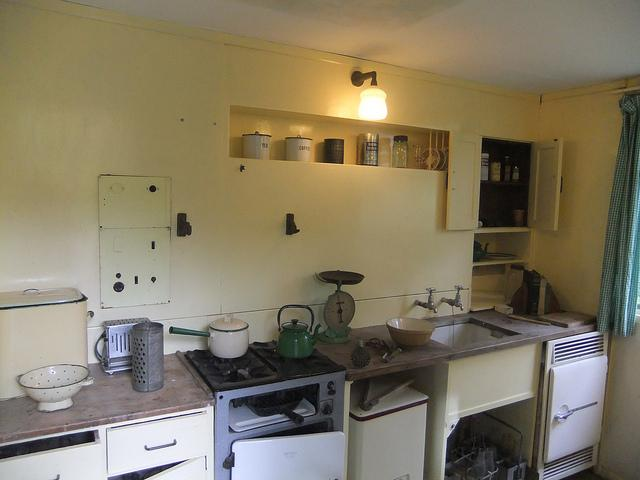What is the white bowl with holes in it on the left used for?

Choices:
A) mashing
B) straining
C) mixing
D) tenderizing straining 